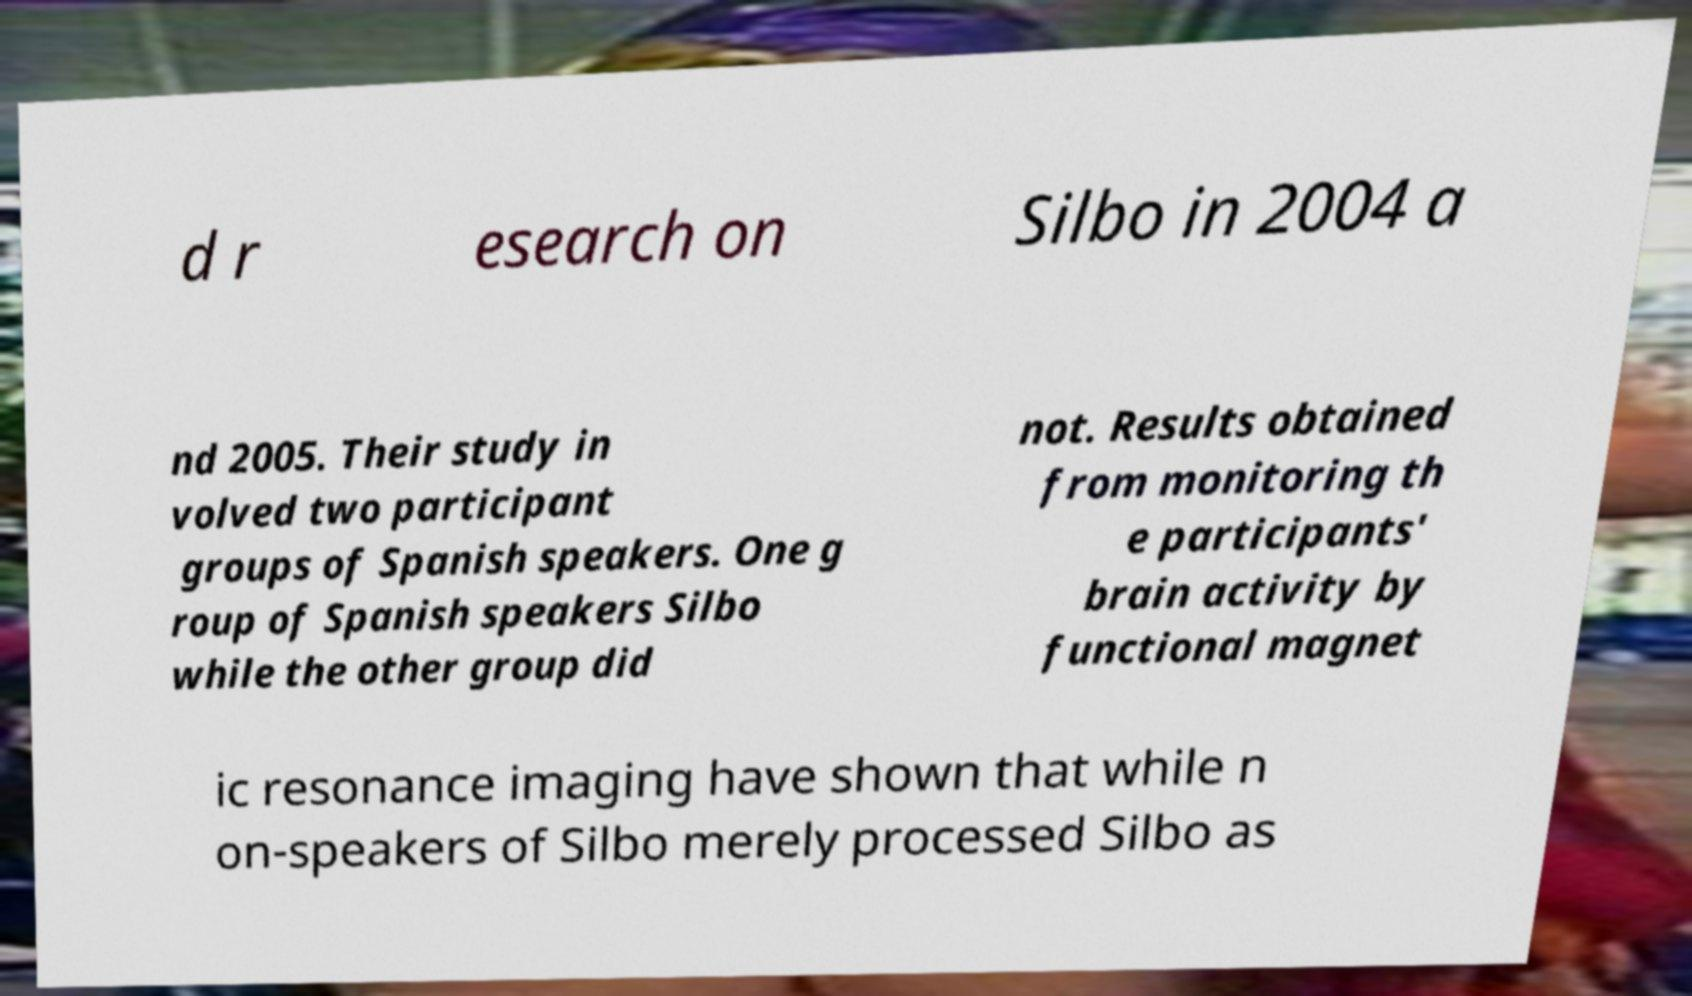Could you assist in decoding the text presented in this image and type it out clearly? d r esearch on Silbo in 2004 a nd 2005. Their study in volved two participant groups of Spanish speakers. One g roup of Spanish speakers Silbo while the other group did not. Results obtained from monitoring th e participants' brain activity by functional magnet ic resonance imaging have shown that while n on-speakers of Silbo merely processed Silbo as 